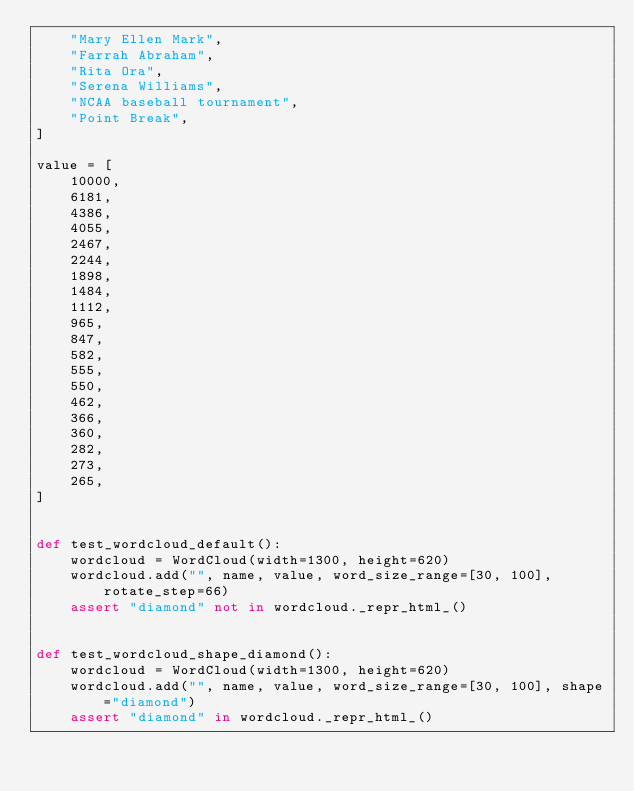Convert code to text. <code><loc_0><loc_0><loc_500><loc_500><_Python_>    "Mary Ellen Mark",
    "Farrah Abraham",
    "Rita Ora",
    "Serena Williams",
    "NCAA baseball tournament",
    "Point Break",
]

value = [
    10000,
    6181,
    4386,
    4055,
    2467,
    2244,
    1898,
    1484,
    1112,
    965,
    847,
    582,
    555,
    550,
    462,
    366,
    360,
    282,
    273,
    265,
]


def test_wordcloud_default():
    wordcloud = WordCloud(width=1300, height=620)
    wordcloud.add("", name, value, word_size_range=[30, 100], rotate_step=66)
    assert "diamond" not in wordcloud._repr_html_()


def test_wordcloud_shape_diamond():
    wordcloud = WordCloud(width=1300, height=620)
    wordcloud.add("", name, value, word_size_range=[30, 100], shape="diamond")
    assert "diamond" in wordcloud._repr_html_()
</code> 